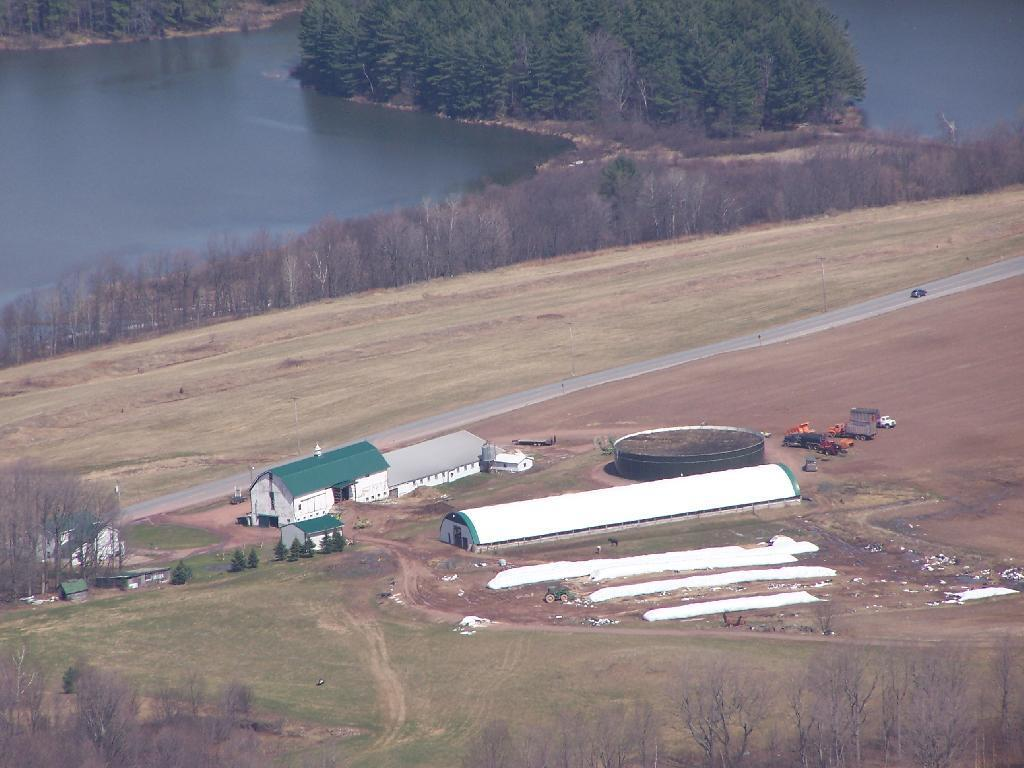What type of structures can be seen in the image? There are buildings in the image. What natural elements are present in the image? There are trees and grass in the image. What man-made objects can be seen in the image? There are vehicles in the image. What body of water is visible in the image? There is water visible in the image. What type of desk can be seen in the image? There is no desk present in the image. What liquid is being poured from the sky in the image? There is no liquid being poured from the sky in the image. 